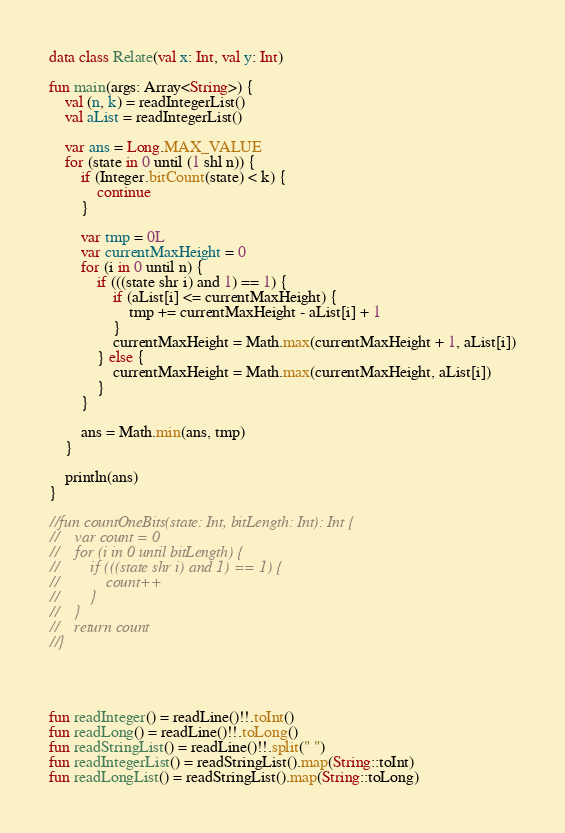Convert code to text. <code><loc_0><loc_0><loc_500><loc_500><_Kotlin_>data class Relate(val x: Int, val y: Int)

fun main(args: Array<String>) {
    val (n, k) = readIntegerList()
    val aList = readIntegerList()

    var ans = Long.MAX_VALUE
    for (state in 0 until (1 shl n)) {
        if (Integer.bitCount(state) < k) {
            continue
        }

        var tmp = 0L
        var currentMaxHeight = 0
        for (i in 0 until n) {
            if (((state shr i) and 1) == 1) {
                if (aList[i] <= currentMaxHeight) {
                    tmp += currentMaxHeight - aList[i] + 1
                }
                currentMaxHeight = Math.max(currentMaxHeight + 1, aList[i])
            } else {
                currentMaxHeight = Math.max(currentMaxHeight, aList[i])
            }
        }

        ans = Math.min(ans, tmp)
    }

    println(ans)
}

//fun countOneBits(state: Int, bitLength: Int): Int {
//    var count = 0
//    for (i in 0 until bitLength) {
//        if (((state shr i) and 1) == 1) {
//            count++
//        }
//    }
//    return count
//}




fun readInteger() = readLine()!!.toInt()
fun readLong() = readLine()!!.toLong()
fun readStringList() = readLine()!!.split(" ")
fun readIntegerList() = readStringList().map(String::toInt)
fun readLongList() = readStringList().map(String::toLong)
</code> 